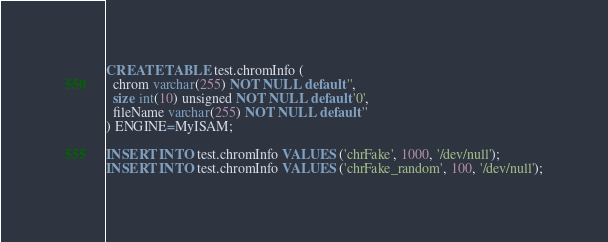<code> <loc_0><loc_0><loc_500><loc_500><_SQL_>
CREATE TABLE test.chromInfo (
  chrom varchar(255) NOT NULL default '',
  size int(10) unsigned NOT NULL default '0',
  fileName varchar(255) NOT NULL default ''
) ENGINE=MyISAM;

INSERT INTO test.chromInfo VALUES ('chrFake', 1000, '/dev/null');
INSERT INTO test.chromInfo VALUES ('chrFake_random', 100, '/dev/null');
</code> 